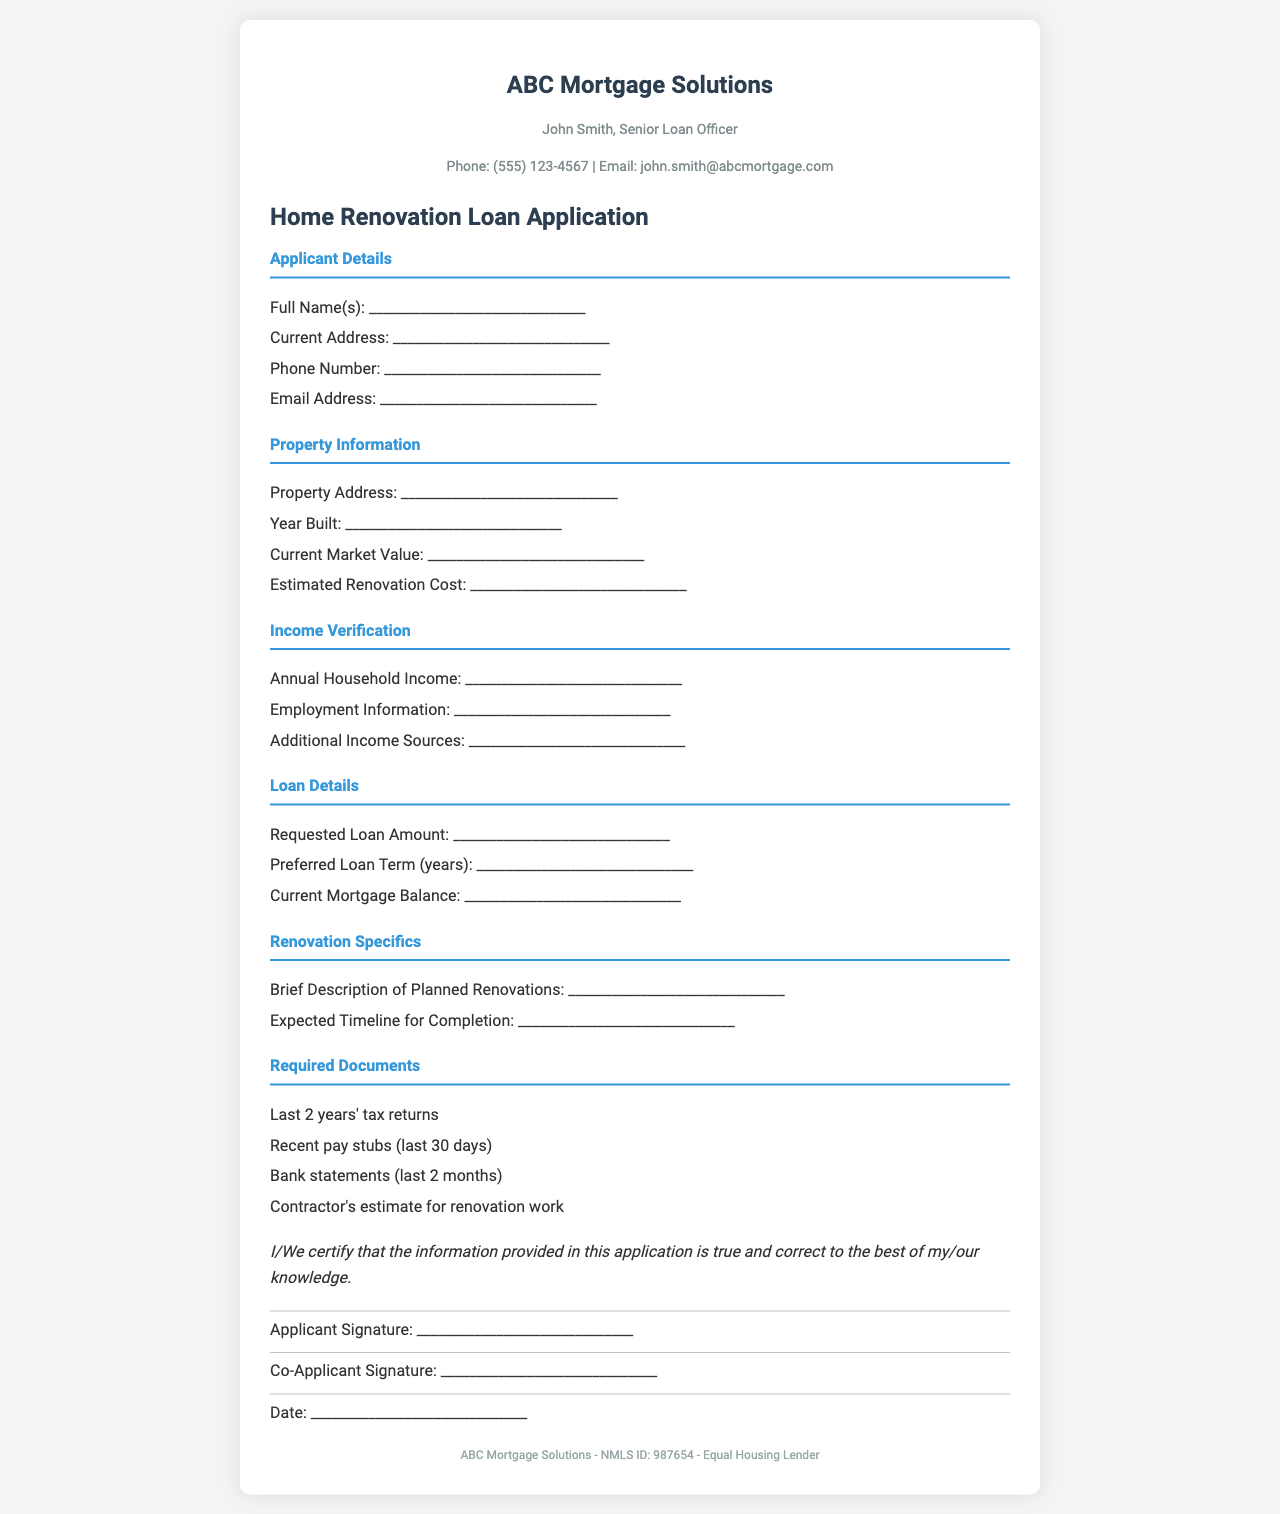what is the title of the document? The title of the document is prominently displayed at the top in large font.
Answer: Home Renovation Loan Application who is the Senior Loan Officer? This information is found in the contact info section of the document.
Answer: John Smith what is the contact phone number? The phone number is listed under the Senior Loan Officer's contact information.
Answer: (555) 123-4567 what should be included in the Required Documents section? This section lists specific items that the applicants must provide.
Answer: Last 2 years' tax returns, recent pay stubs, bank statements, contractor's estimate what is the estimated renovation cost? This field is available in the Property Information section for applicants to fill in.
Answer: ______________________________ what is the current market value of the property? This information is also found in the Property Information section and requires the applicant's input.
Answer: ______________________________ how many years of employment information is needed? The Income Verification section specifies the type of income documents required.
Answer: ______________________________ what is the purpose of the declaration? The declaration is a statement made by the applicant regarding the accuracy of the provided information.
Answer: Certify true and correct information who needs to sign the application? The signature fields indicate who is required to sign the document.
Answer: Applicant and Co-Applicant 